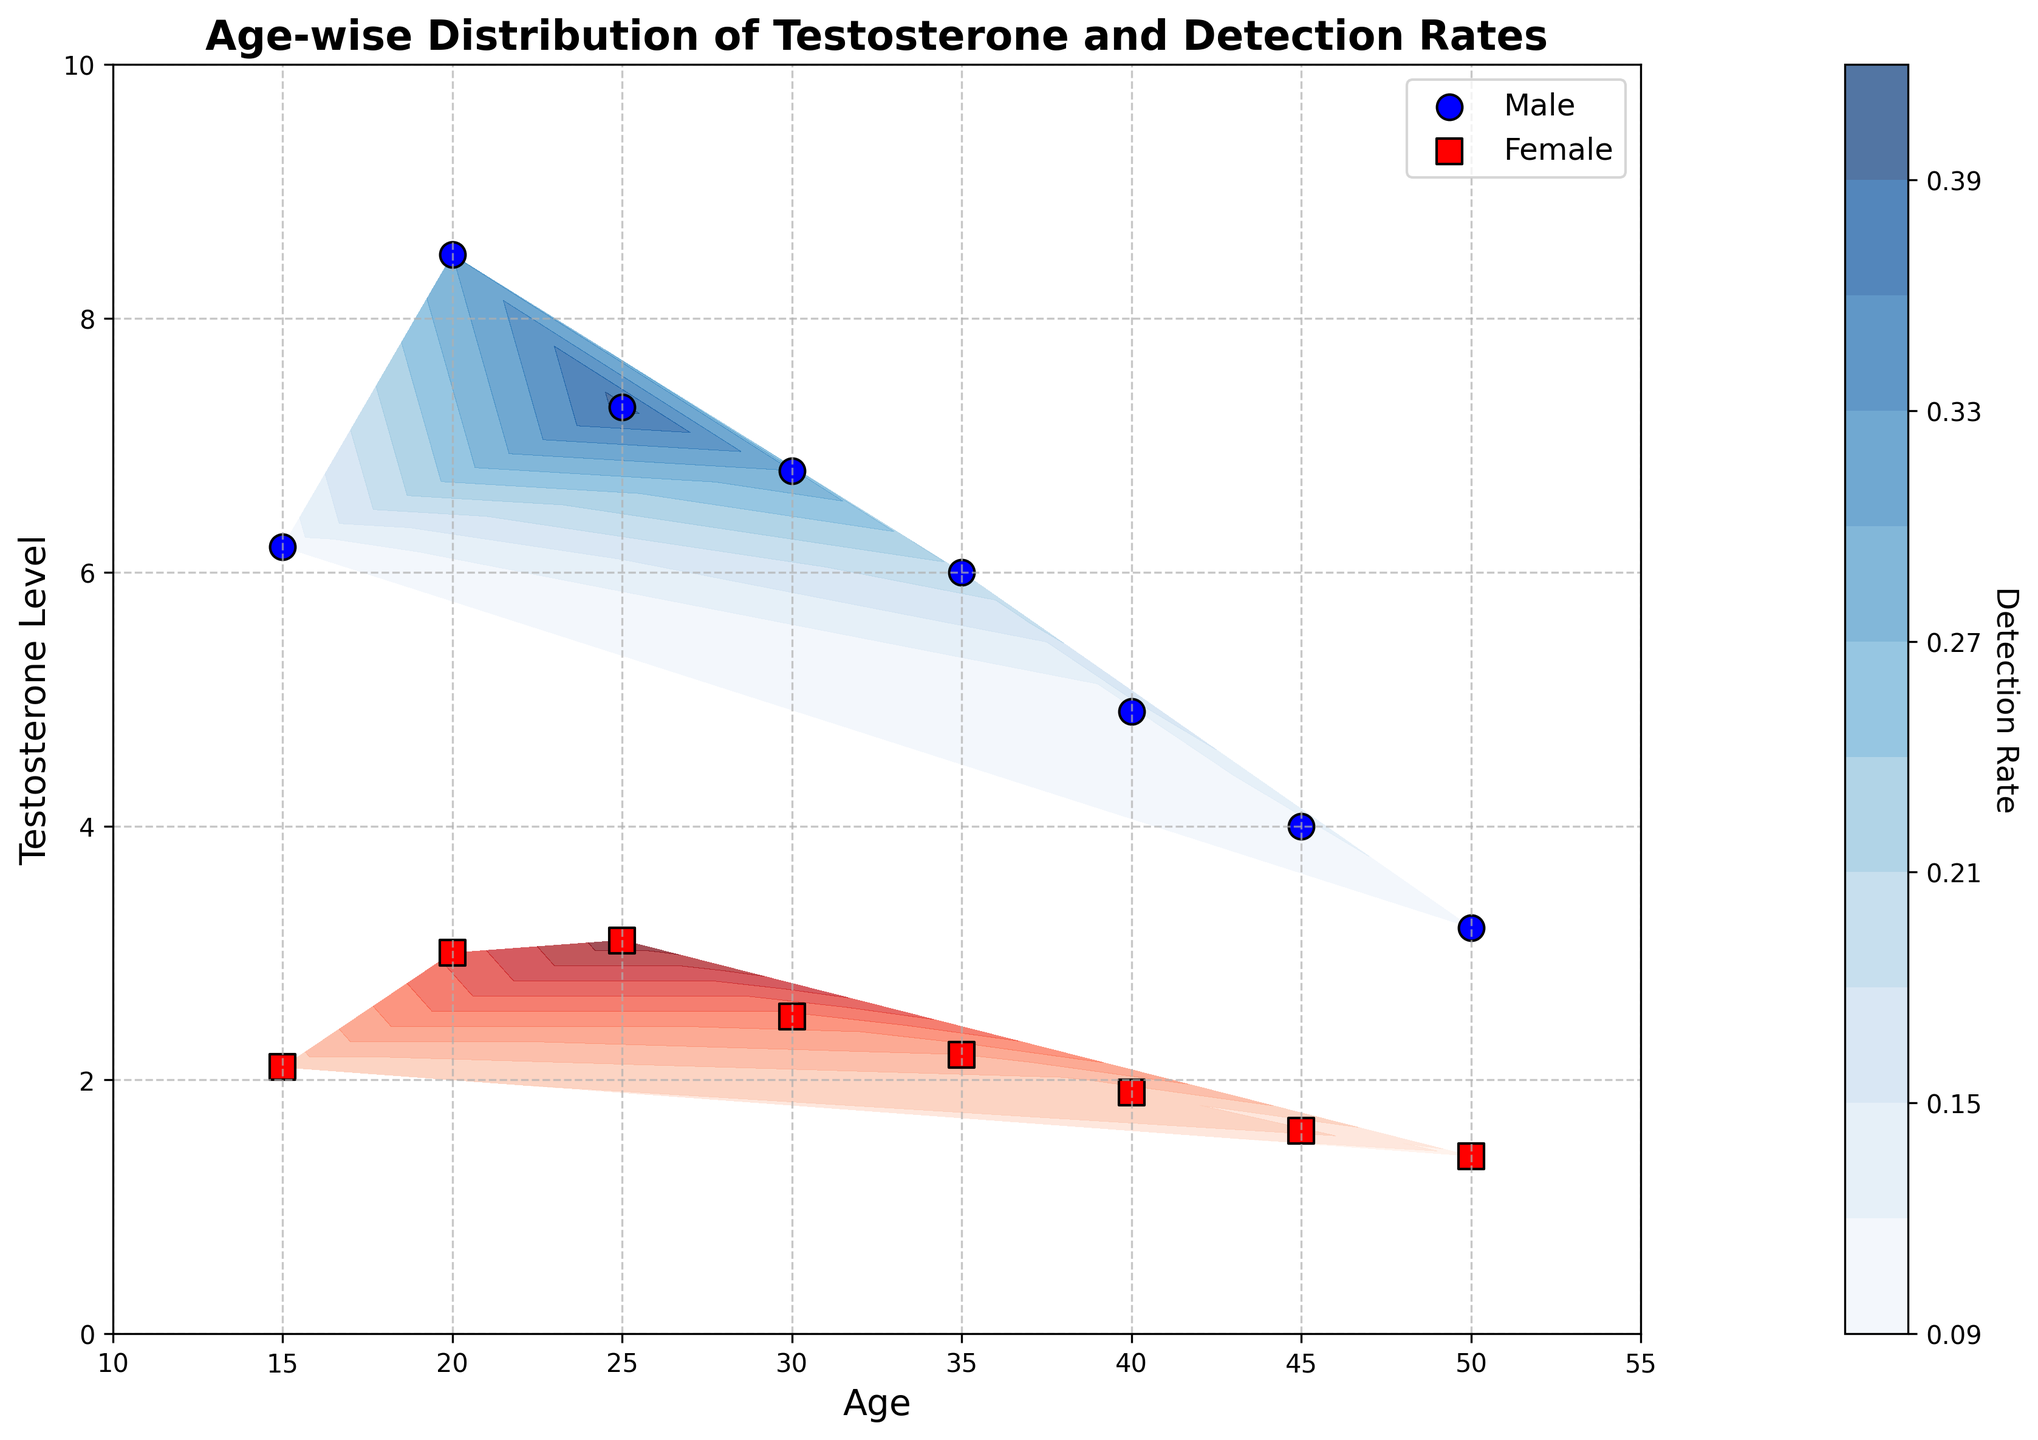What's the title of the figure? The title of the figure is located at the top center of the plot and provides a brief description of the plot contents.
Answer: Age-wise Distribution of Testosterone and Detection Rates What's the x-axis label? The x-axis label is found at the bottom center of the plot and describes what the x-axis represents.
Answer: Age What's the y-axis label? The y-axis label is found on the left side of the plot and describes what the y-axis represents.
Answer: Testosterone Level How many male athletes are represented in the figure? Each male data point is represented by a blue circle, find the number of blue circles in the plot.
Answer: 8 How many female athletes are represented in the figure? Each female data point is represented by a red square, find the number of red squares in the plot.
Answer: 8 Which color represents the detection rates for male athletes in the contour plot? The contour color for male athletes is indicated in the contour area and the color bar; for males, it is shades of blue.
Answer: Blue Which hormone levels are being analyzed for their detection rates in this plot? The levels of the hormone plotted on the y-axis against the detection rates are Testosterone levels.
Answer: Testosterone At what age range do female athletes show the highest detection rate? Identify the red contours that represent the highest detection rates and check the age range on the x-axis that corresponds to these contours.
Answer: 25 How do the testosterone levels in male athletes change with age? Observe the trend of blue circles alongside the age on the x-axis to determine the general tendency of testosterone levels.
Answer: Decrease Do male or female athletes generally have higher testosterone levels? Compare the positions of blue circles (male) and red squares (female) on the y-axis for testosterone levels.
Answer: Male 